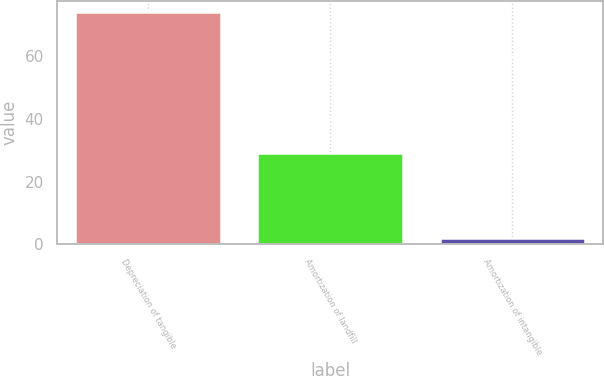<chart> <loc_0><loc_0><loc_500><loc_500><bar_chart><fcel>Depreciation of tangible<fcel>Amortization of landfill<fcel>Amortization of intangible<nl><fcel>74<fcel>29<fcel>2<nl></chart> 